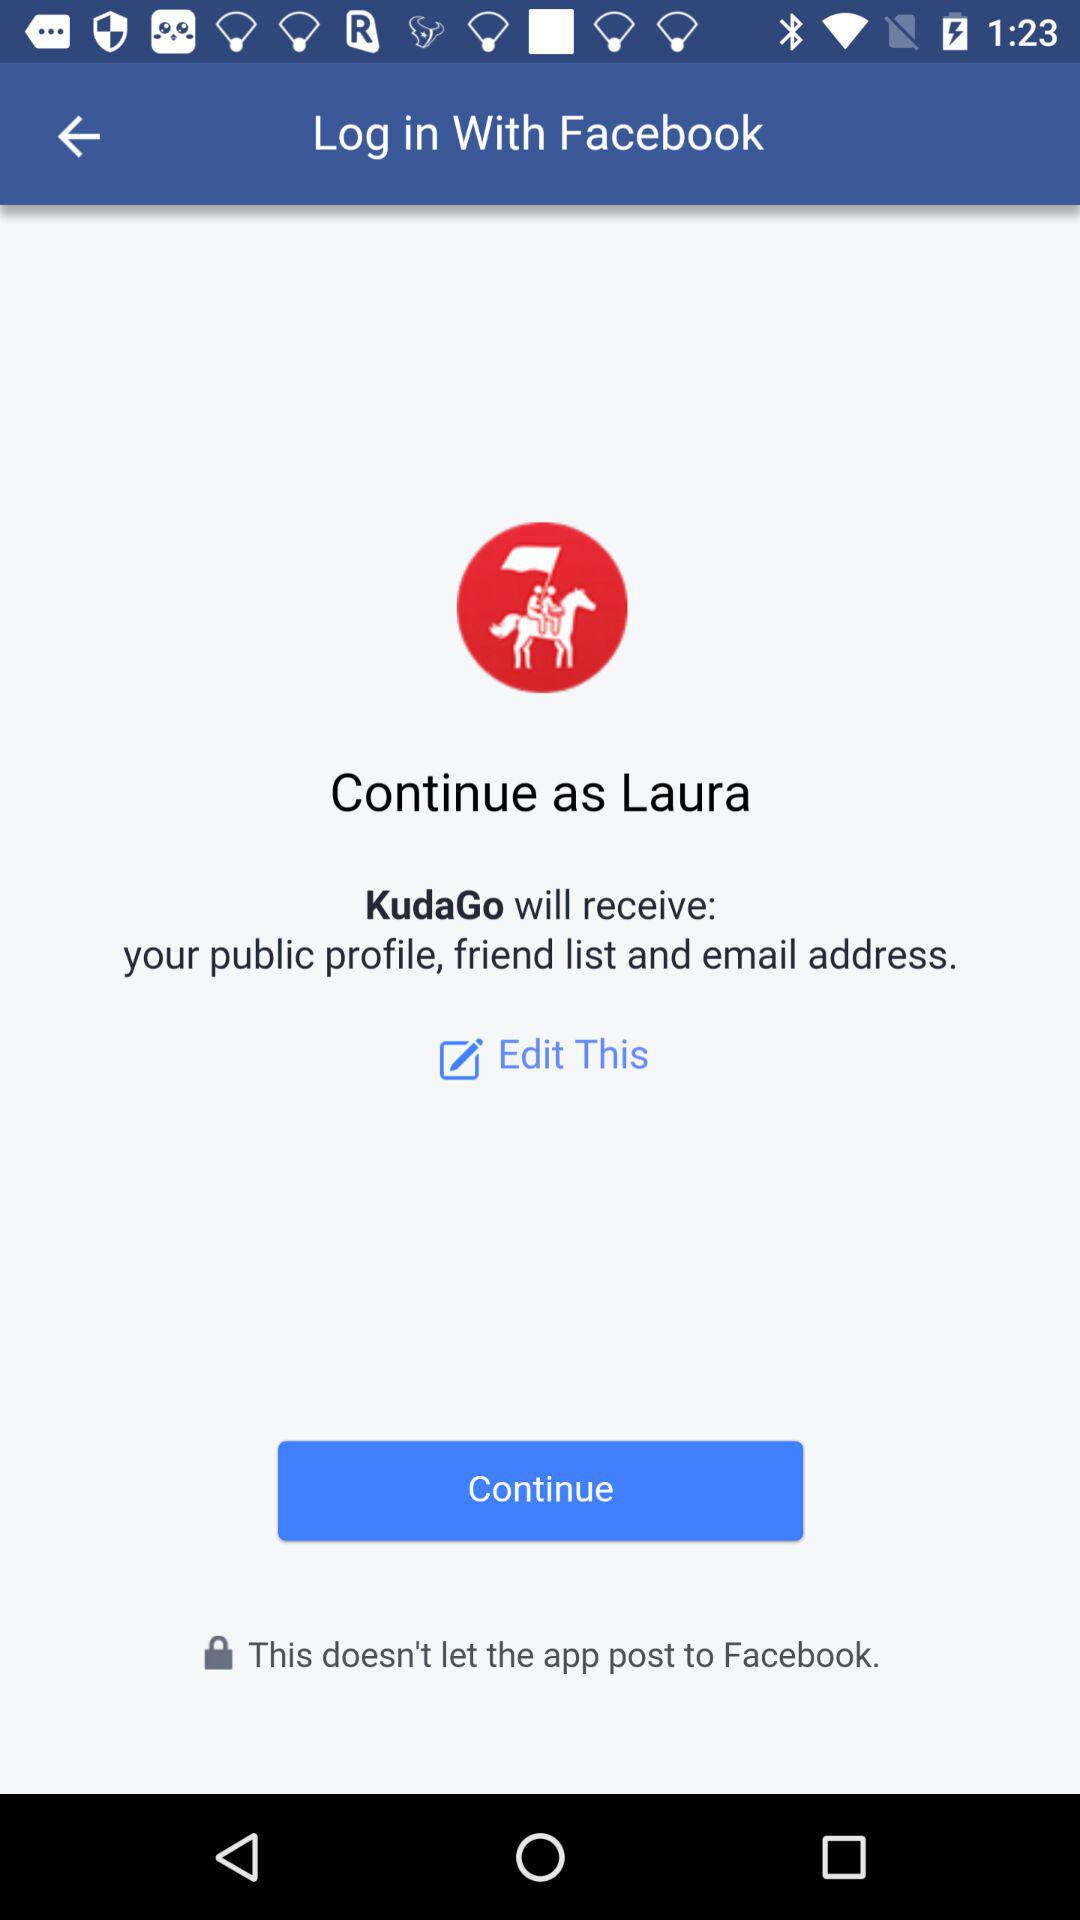What is the user name? The user name is Laura. 